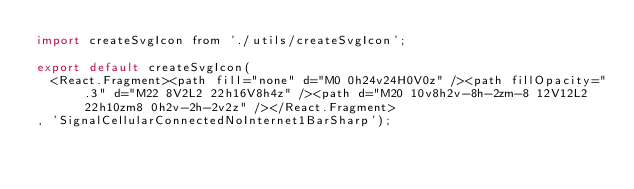<code> <loc_0><loc_0><loc_500><loc_500><_JavaScript_>import createSvgIcon from './utils/createSvgIcon';

export default createSvgIcon(
  <React.Fragment><path fill="none" d="M0 0h24v24H0V0z" /><path fillOpacity=".3" d="M22 8V2L2 22h16V8h4z" /><path d="M20 10v8h2v-8h-2zm-8 12V12L2 22h10zm8 0h2v-2h-2v2z" /></React.Fragment>
, 'SignalCellularConnectedNoInternet1BarSharp');
</code> 